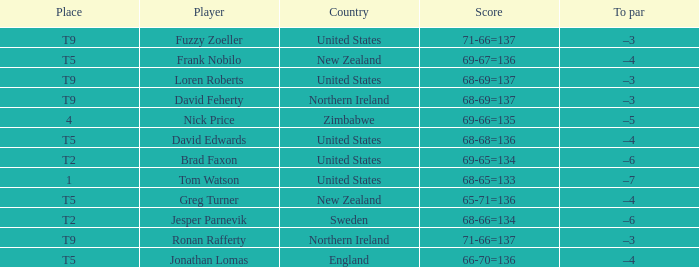With a score of 68-65=133 and United States as the country what is the To par? –7. 